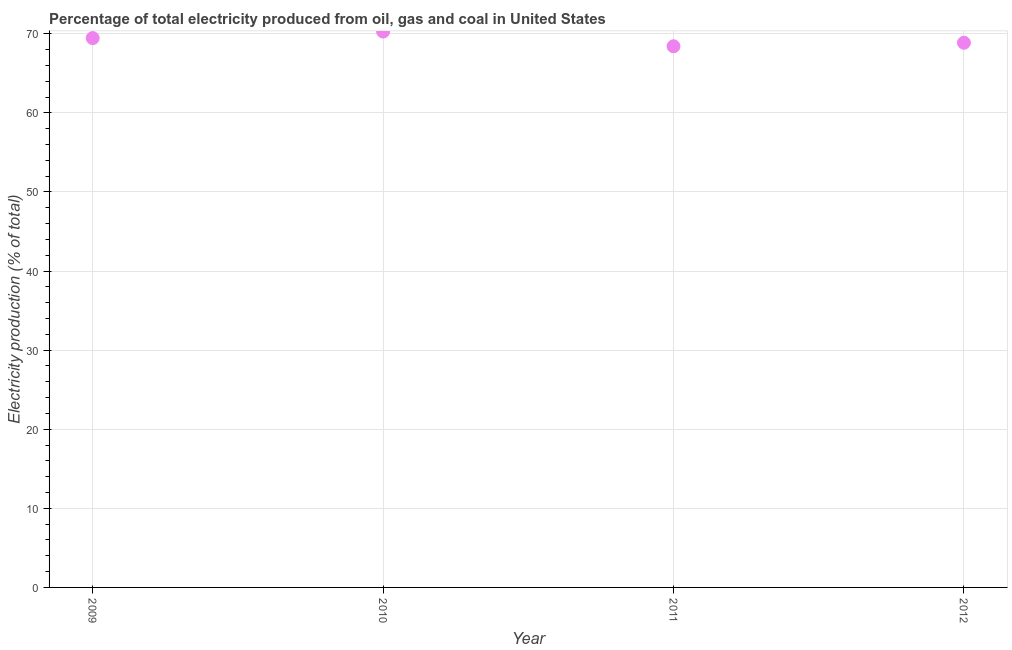What is the electricity production in 2011?
Your response must be concise. 68.42. Across all years, what is the maximum electricity production?
Provide a short and direct response. 70.28. Across all years, what is the minimum electricity production?
Give a very brief answer. 68.42. What is the sum of the electricity production?
Ensure brevity in your answer.  277.01. What is the difference between the electricity production in 2010 and 2011?
Provide a succinct answer. 1.86. What is the average electricity production per year?
Your response must be concise. 69.25. What is the median electricity production?
Provide a succinct answer. 69.16. What is the ratio of the electricity production in 2009 to that in 2010?
Offer a terse response. 0.99. What is the difference between the highest and the second highest electricity production?
Provide a short and direct response. 0.83. Is the sum of the electricity production in 2010 and 2011 greater than the maximum electricity production across all years?
Offer a very short reply. Yes. What is the difference between the highest and the lowest electricity production?
Offer a terse response. 1.86. What is the difference between two consecutive major ticks on the Y-axis?
Offer a very short reply. 10. Does the graph contain any zero values?
Provide a succinct answer. No. Does the graph contain grids?
Your answer should be very brief. Yes. What is the title of the graph?
Your answer should be compact. Percentage of total electricity produced from oil, gas and coal in United States. What is the label or title of the Y-axis?
Your answer should be very brief. Electricity production (% of total). What is the Electricity production (% of total) in 2009?
Give a very brief answer. 69.45. What is the Electricity production (% of total) in 2010?
Ensure brevity in your answer.  70.28. What is the Electricity production (% of total) in 2011?
Your answer should be very brief. 68.42. What is the Electricity production (% of total) in 2012?
Provide a short and direct response. 68.86. What is the difference between the Electricity production (% of total) in 2009 and 2010?
Offer a very short reply. -0.83. What is the difference between the Electricity production (% of total) in 2009 and 2011?
Keep it short and to the point. 1.03. What is the difference between the Electricity production (% of total) in 2009 and 2012?
Ensure brevity in your answer.  0.59. What is the difference between the Electricity production (% of total) in 2010 and 2011?
Provide a short and direct response. 1.86. What is the difference between the Electricity production (% of total) in 2010 and 2012?
Give a very brief answer. 1.41. What is the difference between the Electricity production (% of total) in 2011 and 2012?
Make the answer very short. -0.45. What is the ratio of the Electricity production (% of total) in 2009 to that in 2011?
Your answer should be compact. 1.01. What is the ratio of the Electricity production (% of total) in 2009 to that in 2012?
Give a very brief answer. 1.01. 